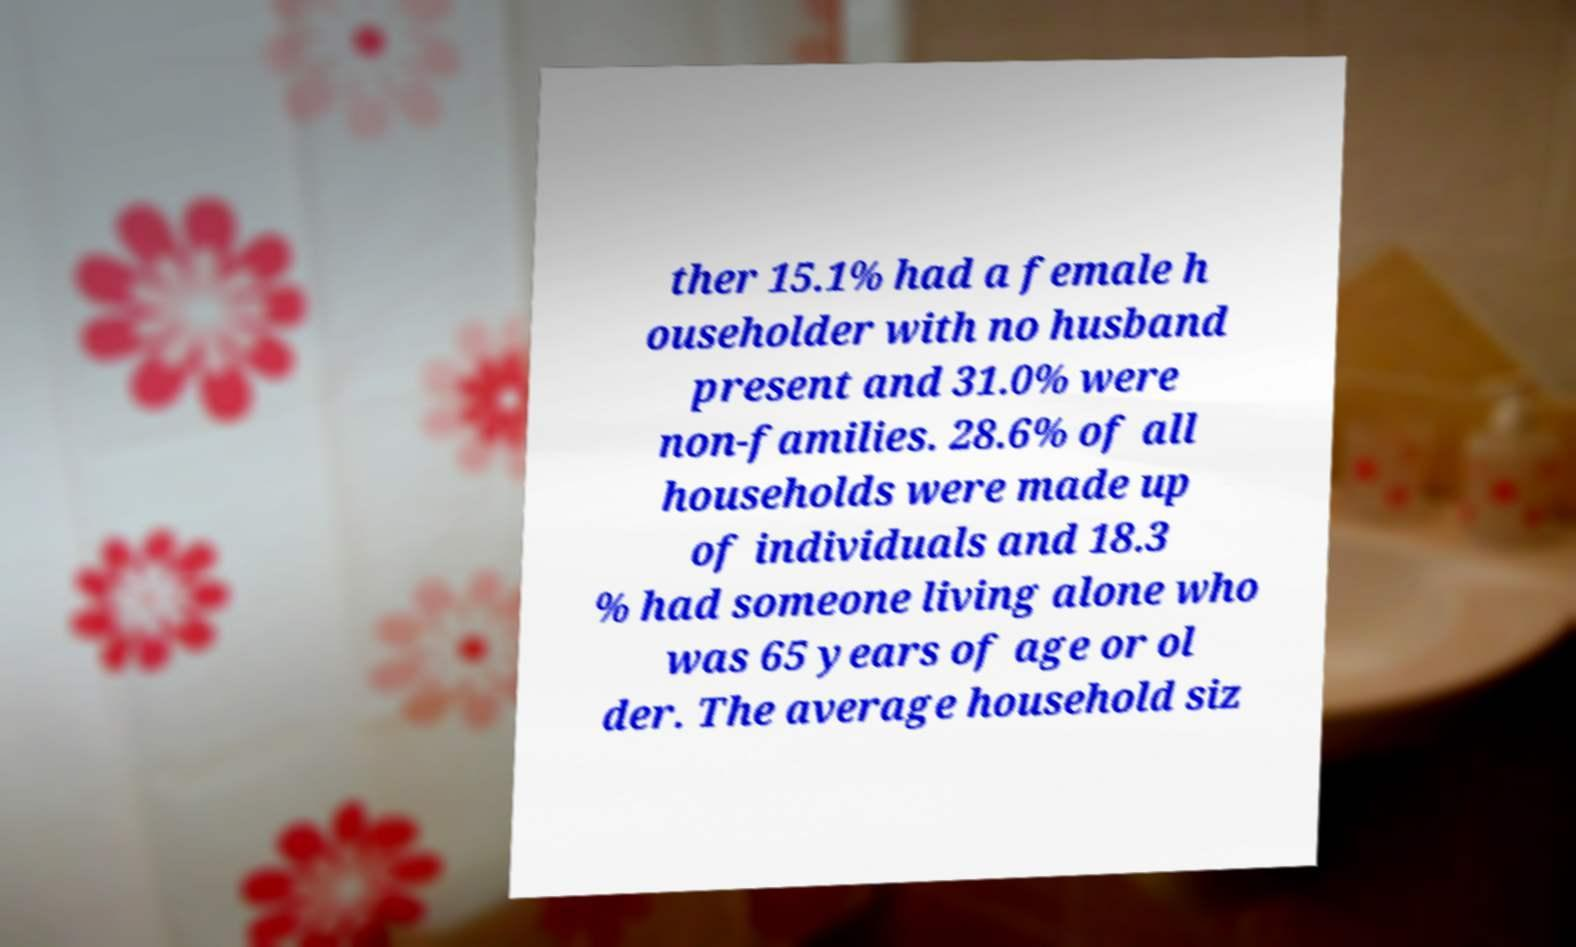Could you assist in decoding the text presented in this image and type it out clearly? ther 15.1% had a female h ouseholder with no husband present and 31.0% were non-families. 28.6% of all households were made up of individuals and 18.3 % had someone living alone who was 65 years of age or ol der. The average household siz 